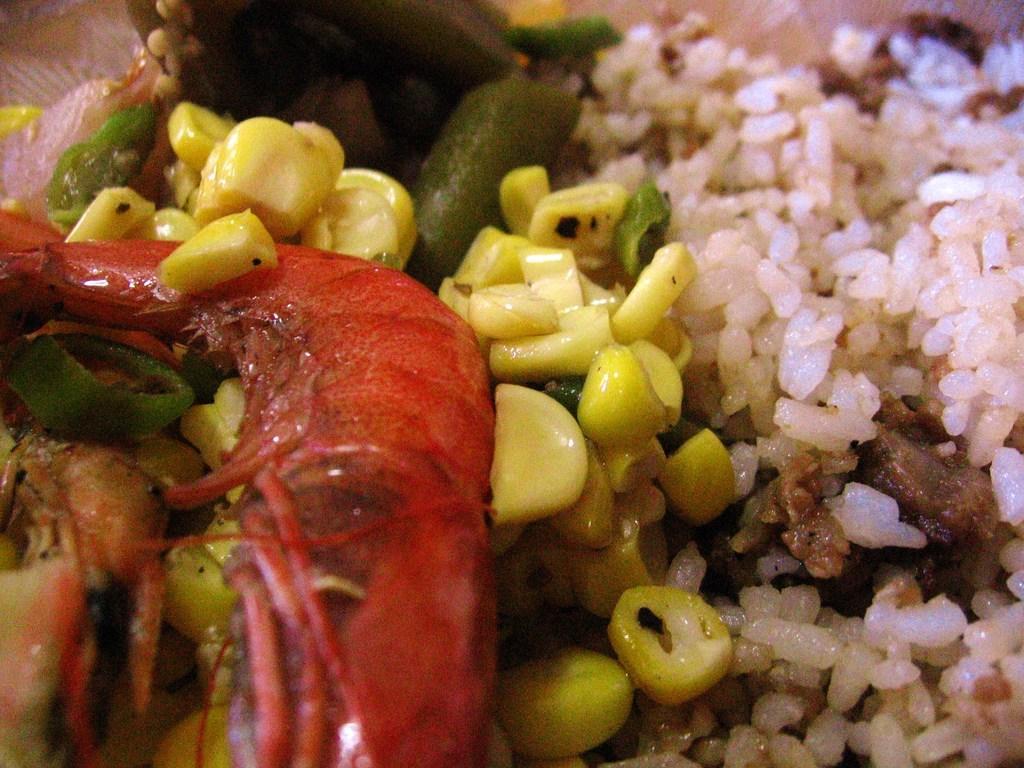In one or two sentences, can you explain what this image depicts? Here in this picture we can see rice, corn , meat and vegetables, all present over there. 